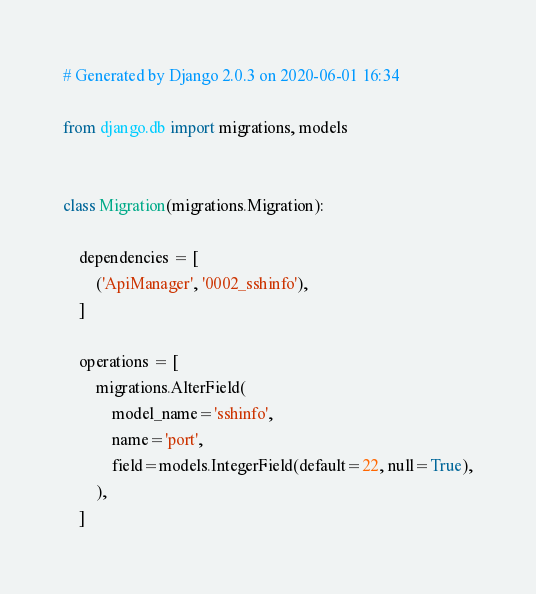Convert code to text. <code><loc_0><loc_0><loc_500><loc_500><_Python_># Generated by Django 2.0.3 on 2020-06-01 16:34

from django.db import migrations, models


class Migration(migrations.Migration):

    dependencies = [
        ('ApiManager', '0002_sshinfo'),
    ]

    operations = [
        migrations.AlterField(
            model_name='sshinfo',
            name='port',
            field=models.IntegerField(default=22, null=True),
        ),
    ]
</code> 